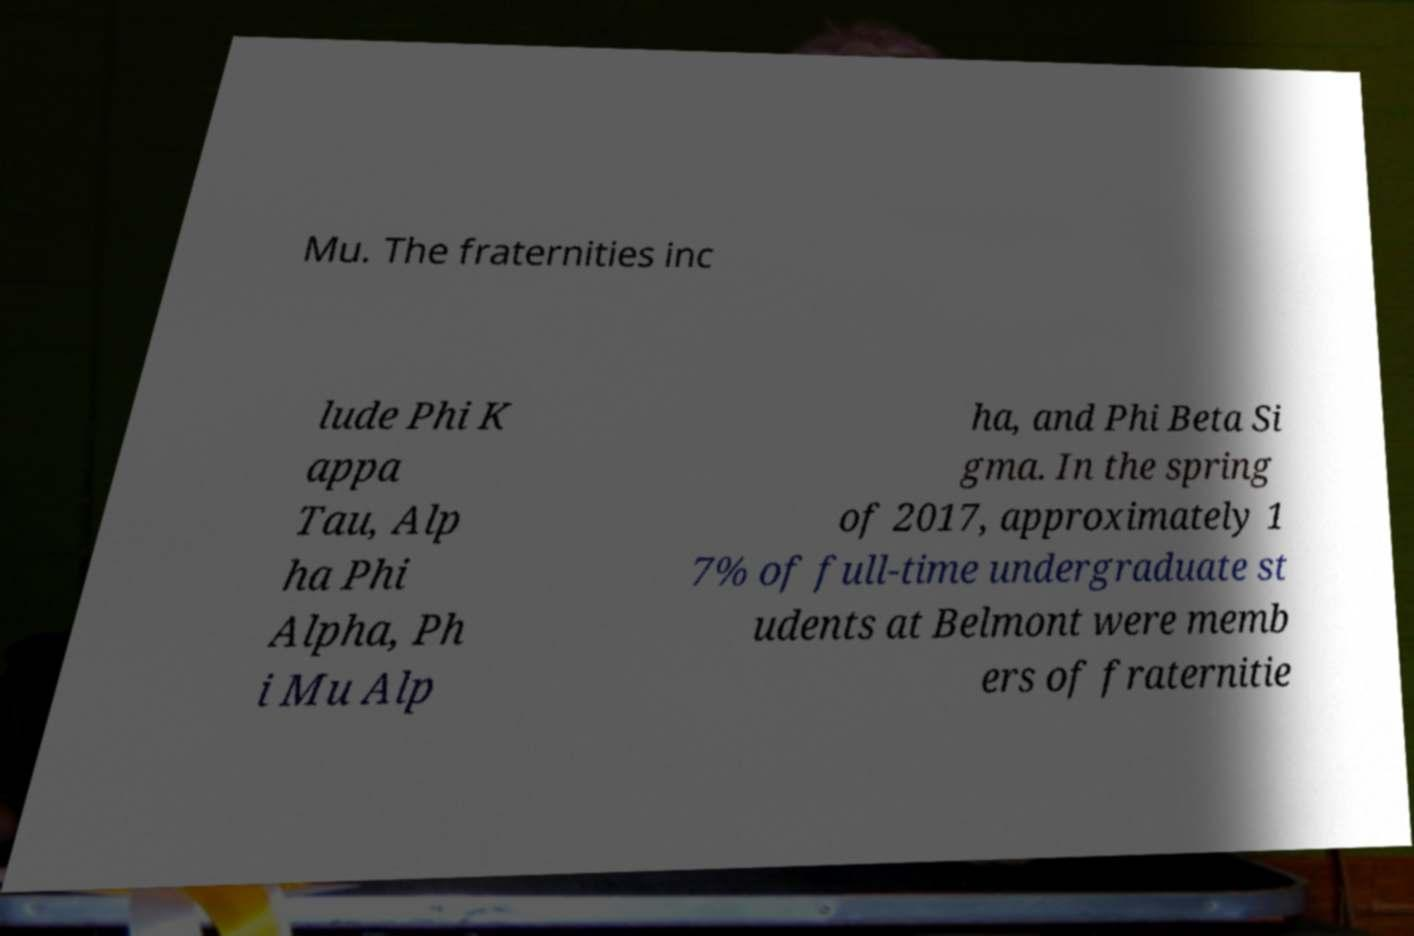There's text embedded in this image that I need extracted. Can you transcribe it verbatim? Mu. The fraternities inc lude Phi K appa Tau, Alp ha Phi Alpha, Ph i Mu Alp ha, and Phi Beta Si gma. In the spring of 2017, approximately 1 7% of full-time undergraduate st udents at Belmont were memb ers of fraternitie 